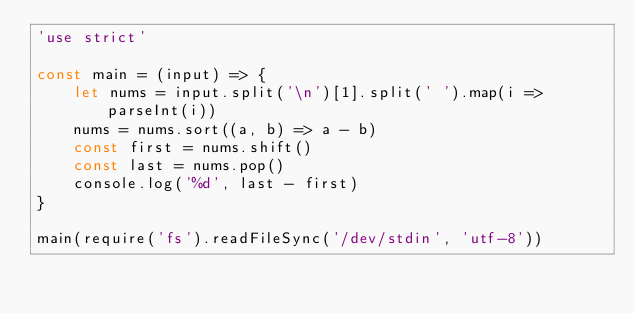<code> <loc_0><loc_0><loc_500><loc_500><_JavaScript_>'use strict'

const main = (input) => {
    let nums = input.split('\n')[1].split(' ').map(i => parseInt(i))
    nums = nums.sort((a, b) => a - b)
    const first = nums.shift()
    const last = nums.pop()
    console.log('%d', last - first)
}

main(require('fs').readFileSync('/dev/stdin', 'utf-8'))</code> 